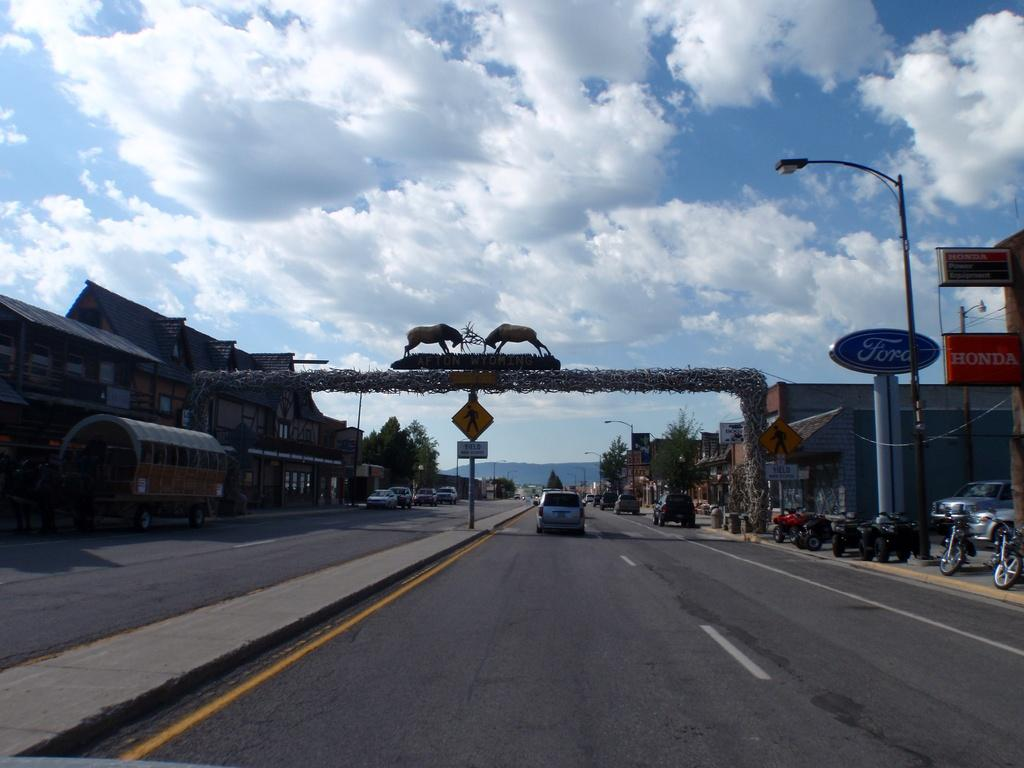What can be seen on the road in the image? There are vehicles on the road in the image. What type of vegetation is present in the image? There are trees in the image. What objects are present in the image that might be used for displaying information or advertisements? There are boards in the image. What type of lighting is present in the image? There are lights attached to poles in the image. What type of artwork or sculptures can be seen in the image? There are statues in the image. What type of architectural feature is present in the image? There is an arch in the image. What type of structures can be seen in the image? There are buildings in the image. What part of the natural environment is visible in the background of the image? The sky is visible in the background of the image. Where can the toothpaste be found in the image? There is no toothpaste present in the image. How many worms can be seen crawling on the vehicles in the image? There are no worms present in the image. 